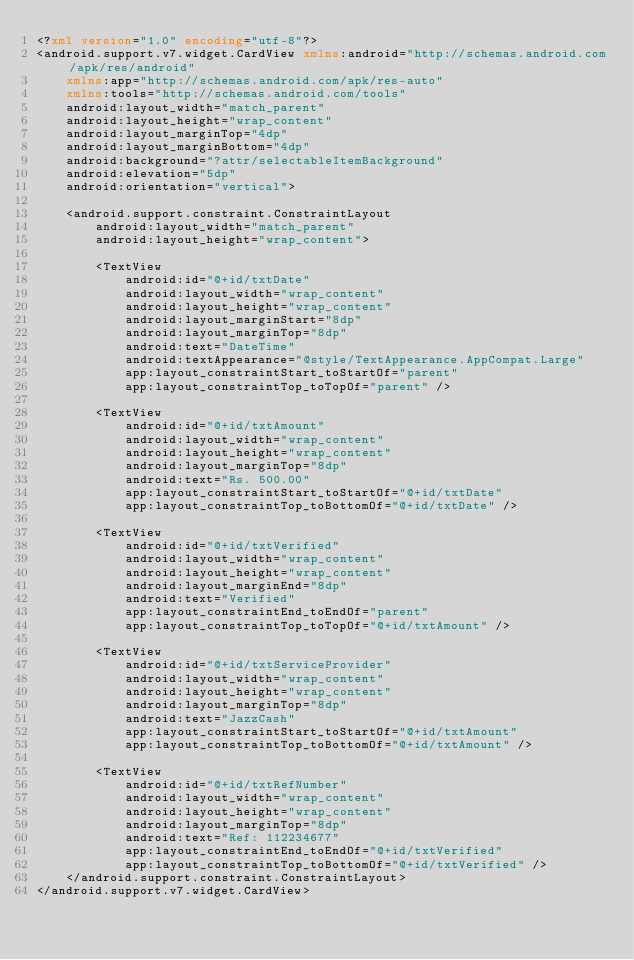Convert code to text. <code><loc_0><loc_0><loc_500><loc_500><_XML_><?xml version="1.0" encoding="utf-8"?>
<android.support.v7.widget.CardView xmlns:android="http://schemas.android.com/apk/res/android"
    xmlns:app="http://schemas.android.com/apk/res-auto"
    xmlns:tools="http://schemas.android.com/tools"
    android:layout_width="match_parent"
    android:layout_height="wrap_content"
    android:layout_marginTop="4dp"
    android:layout_marginBottom="4dp"
    android:background="?attr/selectableItemBackground"
    android:elevation="5dp"
    android:orientation="vertical">

    <android.support.constraint.ConstraintLayout
        android:layout_width="match_parent"
        android:layout_height="wrap_content">

        <TextView
            android:id="@+id/txtDate"
            android:layout_width="wrap_content"
            android:layout_height="wrap_content"
            android:layout_marginStart="8dp"
            android:layout_marginTop="8dp"
            android:text="DateTime"
            android:textAppearance="@style/TextAppearance.AppCompat.Large"
            app:layout_constraintStart_toStartOf="parent"
            app:layout_constraintTop_toTopOf="parent" />

        <TextView
            android:id="@+id/txtAmount"
            android:layout_width="wrap_content"
            android:layout_height="wrap_content"
            android:layout_marginTop="8dp"
            android:text="Rs. 500.00"
            app:layout_constraintStart_toStartOf="@+id/txtDate"
            app:layout_constraintTop_toBottomOf="@+id/txtDate" />

        <TextView
            android:id="@+id/txtVerified"
            android:layout_width="wrap_content"
            android:layout_height="wrap_content"
            android:layout_marginEnd="8dp"
            android:text="Verified"
            app:layout_constraintEnd_toEndOf="parent"
            app:layout_constraintTop_toTopOf="@+id/txtAmount" />

        <TextView
            android:id="@+id/txtServiceProvider"
            android:layout_width="wrap_content"
            android:layout_height="wrap_content"
            android:layout_marginTop="8dp"
            android:text="JazzCash"
            app:layout_constraintStart_toStartOf="@+id/txtAmount"
            app:layout_constraintTop_toBottomOf="@+id/txtAmount" />

        <TextView
            android:id="@+id/txtRefNumber"
            android:layout_width="wrap_content"
            android:layout_height="wrap_content"
            android:layout_marginTop="8dp"
            android:text="Ref: 112234677"
            app:layout_constraintEnd_toEndOf="@+id/txtVerified"
            app:layout_constraintTop_toBottomOf="@+id/txtVerified" />
    </android.support.constraint.ConstraintLayout>
</android.support.v7.widget.CardView></code> 